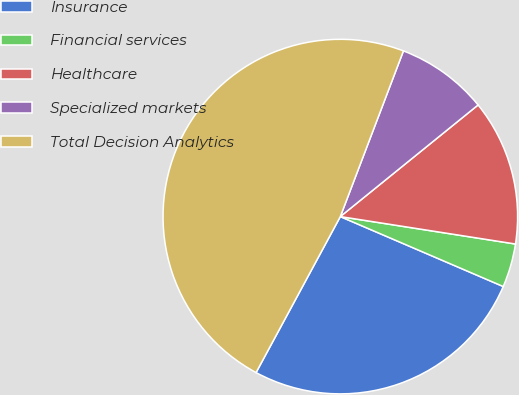Convert chart. <chart><loc_0><loc_0><loc_500><loc_500><pie_chart><fcel>Insurance<fcel>Financial services<fcel>Healthcare<fcel>Specialized markets<fcel>Total Decision Analytics<nl><fcel>26.43%<fcel>3.98%<fcel>13.31%<fcel>8.37%<fcel>47.91%<nl></chart> 